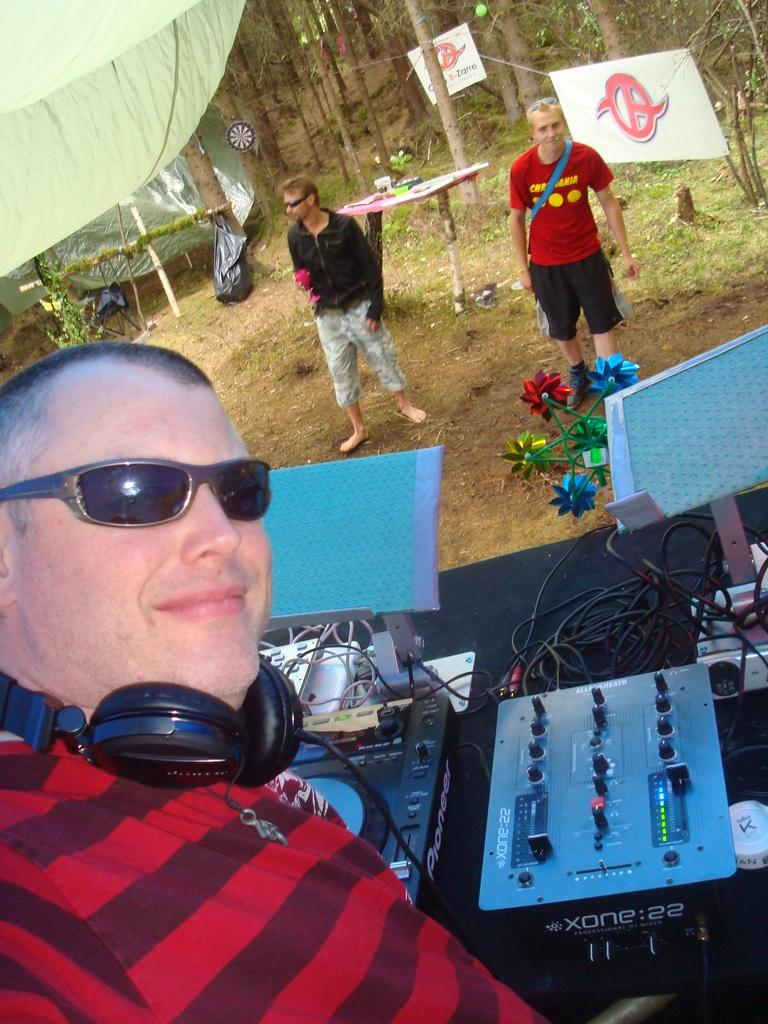What is the man in the image doing? The man is playing DJ. What is the man wearing? The man is wearing a red T-shirt. Can you describe the people in the background? There are two men standing in the background. What can be seen in the background besides the people? There are many trees in the background. What structure is visible at the top of the image? There is a tent visible at the top of the image. How many feet of wax are required to make candles for the tent in the image? There is no information about candles or wax in the image, so it is impossible to determine the amount of wax needed. 